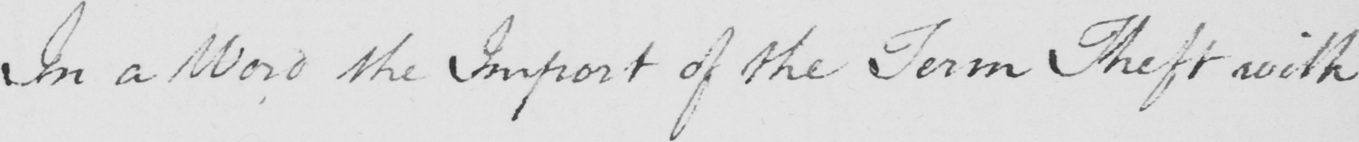Can you tell me what this handwritten text says? In a Word the Import of the Term Theft with 